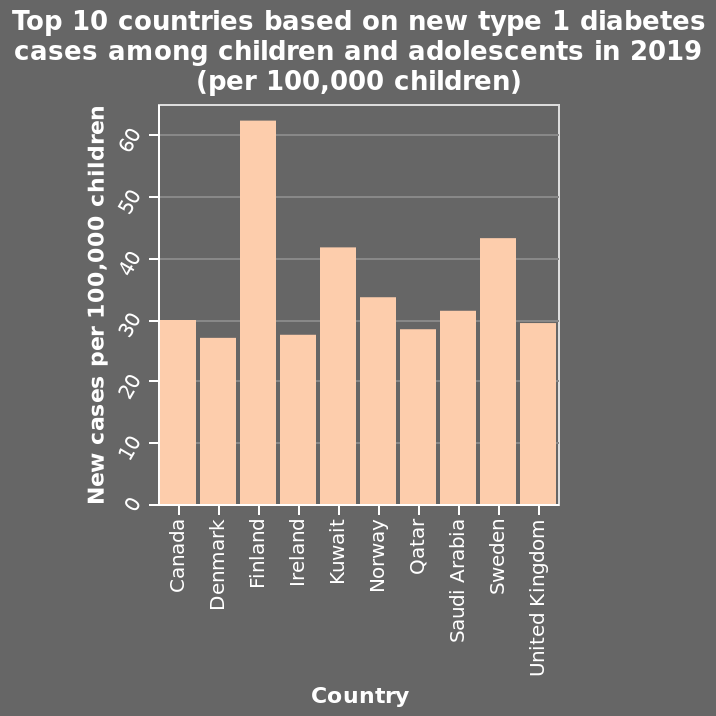<image>
What is the range of the y-axis on the bar graph?  The range of the y-axis on the bar graph is from 0 to 60. What is the title of the bar graph?  The title of the bar graph is "Top 10 countries based on new type 1 diabetes cases among children and adolescents in 2019 (per 100,000 children)". Which country has the highest number of new cases per 100,000 children?  Finland Which country is represented on the far right of the x-axis? The United Kingdom is represented on the far right of the x-axis. 